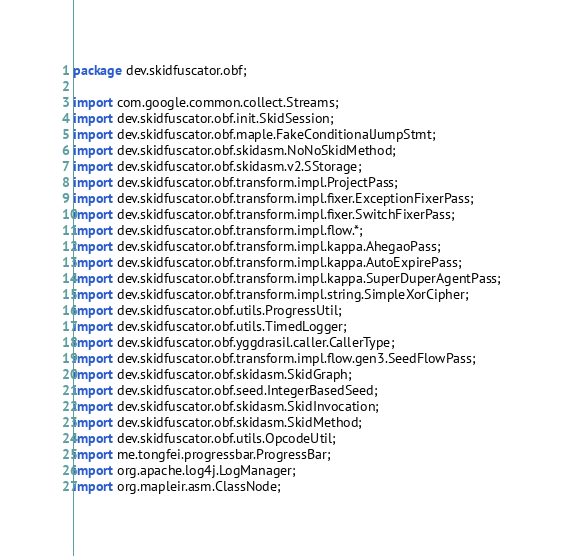<code> <loc_0><loc_0><loc_500><loc_500><_Java_>package dev.skidfuscator.obf;

import com.google.common.collect.Streams;
import dev.skidfuscator.obf.init.SkidSession;
import dev.skidfuscator.obf.maple.FakeConditionalJumpStmt;
import dev.skidfuscator.obf.skidasm.NoNoSkidMethod;
import dev.skidfuscator.obf.skidasm.v2.SStorage;
import dev.skidfuscator.obf.transform.impl.ProjectPass;
import dev.skidfuscator.obf.transform.impl.fixer.ExceptionFixerPass;
import dev.skidfuscator.obf.transform.impl.fixer.SwitchFixerPass;
import dev.skidfuscator.obf.transform.impl.flow.*;
import dev.skidfuscator.obf.transform.impl.kappa.AhegaoPass;
import dev.skidfuscator.obf.transform.impl.kappa.AutoExpirePass;
import dev.skidfuscator.obf.transform.impl.kappa.SuperDuperAgentPass;
import dev.skidfuscator.obf.transform.impl.string.SimpleXorCipher;
import dev.skidfuscator.obf.utils.ProgressUtil;
import dev.skidfuscator.obf.utils.TimedLogger;
import dev.skidfuscator.obf.yggdrasil.caller.CallerType;
import dev.skidfuscator.obf.transform.impl.flow.gen3.SeedFlowPass;
import dev.skidfuscator.obf.skidasm.SkidGraph;
import dev.skidfuscator.obf.seed.IntegerBasedSeed;
import dev.skidfuscator.obf.skidasm.SkidInvocation;
import dev.skidfuscator.obf.skidasm.SkidMethod;
import dev.skidfuscator.obf.utils.OpcodeUtil;
import me.tongfei.progressbar.ProgressBar;
import org.apache.log4j.LogManager;
import org.mapleir.asm.ClassNode;</code> 